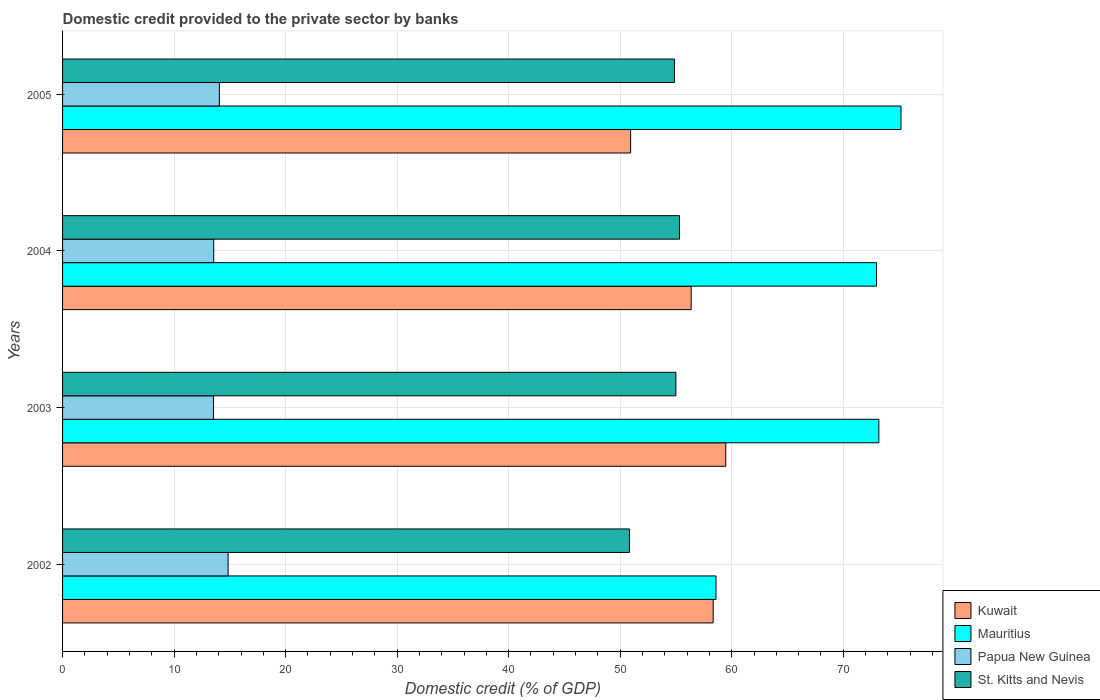How many different coloured bars are there?
Your answer should be compact. 4. How many groups of bars are there?
Offer a terse response. 4. Are the number of bars per tick equal to the number of legend labels?
Give a very brief answer. Yes. How many bars are there on the 4th tick from the top?
Ensure brevity in your answer.  4. What is the label of the 2nd group of bars from the top?
Offer a terse response. 2004. What is the domestic credit provided to the private sector by banks in St. Kitts and Nevis in 2004?
Provide a succinct answer. 55.32. Across all years, what is the maximum domestic credit provided to the private sector by banks in Mauritius?
Provide a succinct answer. 75.18. Across all years, what is the minimum domestic credit provided to the private sector by banks in Papua New Guinea?
Offer a very short reply. 13.53. In which year was the domestic credit provided to the private sector by banks in St. Kitts and Nevis minimum?
Give a very brief answer. 2002. What is the total domestic credit provided to the private sector by banks in St. Kitts and Nevis in the graph?
Ensure brevity in your answer.  216.01. What is the difference between the domestic credit provided to the private sector by banks in Kuwait in 2003 and that in 2005?
Your answer should be compact. 8.53. What is the difference between the domestic credit provided to the private sector by banks in Mauritius in 2004 and the domestic credit provided to the private sector by banks in Kuwait in 2003?
Keep it short and to the point. 13.52. What is the average domestic credit provided to the private sector by banks in St. Kitts and Nevis per year?
Give a very brief answer. 54. In the year 2003, what is the difference between the domestic credit provided to the private sector by banks in St. Kitts and Nevis and domestic credit provided to the private sector by banks in Kuwait?
Your answer should be compact. -4.47. What is the ratio of the domestic credit provided to the private sector by banks in St. Kitts and Nevis in 2002 to that in 2004?
Keep it short and to the point. 0.92. Is the domestic credit provided to the private sector by banks in Papua New Guinea in 2004 less than that in 2005?
Your response must be concise. Yes. What is the difference between the highest and the second highest domestic credit provided to the private sector by banks in St. Kitts and Nevis?
Provide a short and direct response. 0.33. What is the difference between the highest and the lowest domestic credit provided to the private sector by banks in Papua New Guinea?
Offer a very short reply. 1.31. In how many years, is the domestic credit provided to the private sector by banks in Mauritius greater than the average domestic credit provided to the private sector by banks in Mauritius taken over all years?
Make the answer very short. 3. Is the sum of the domestic credit provided to the private sector by banks in Mauritius in 2002 and 2005 greater than the maximum domestic credit provided to the private sector by banks in Kuwait across all years?
Provide a succinct answer. Yes. What does the 4th bar from the top in 2005 represents?
Provide a succinct answer. Kuwait. What does the 1st bar from the bottom in 2005 represents?
Give a very brief answer. Kuwait. How many bars are there?
Give a very brief answer. 16. How many years are there in the graph?
Ensure brevity in your answer.  4. Are the values on the major ticks of X-axis written in scientific E-notation?
Your answer should be compact. No. Does the graph contain grids?
Offer a very short reply. Yes. How are the legend labels stacked?
Offer a very short reply. Vertical. What is the title of the graph?
Your answer should be very brief. Domestic credit provided to the private sector by banks. What is the label or title of the X-axis?
Provide a short and direct response. Domestic credit (% of GDP). What is the Domestic credit (% of GDP) in Kuwait in 2002?
Offer a very short reply. 58.34. What is the Domestic credit (% of GDP) in Mauritius in 2002?
Ensure brevity in your answer.  58.59. What is the Domestic credit (% of GDP) of Papua New Guinea in 2002?
Your response must be concise. 14.84. What is the Domestic credit (% of GDP) in St. Kitts and Nevis in 2002?
Your answer should be very brief. 50.83. What is the Domestic credit (% of GDP) in Kuwait in 2003?
Your answer should be very brief. 59.47. What is the Domestic credit (% of GDP) of Mauritius in 2003?
Your answer should be compact. 73.19. What is the Domestic credit (% of GDP) of Papua New Guinea in 2003?
Your response must be concise. 13.53. What is the Domestic credit (% of GDP) of St. Kitts and Nevis in 2003?
Give a very brief answer. 54.99. What is the Domestic credit (% of GDP) of Kuwait in 2004?
Your answer should be compact. 56.36. What is the Domestic credit (% of GDP) in Mauritius in 2004?
Offer a very short reply. 72.99. What is the Domestic credit (% of GDP) of Papua New Guinea in 2004?
Your answer should be very brief. 13.56. What is the Domestic credit (% of GDP) in St. Kitts and Nevis in 2004?
Your answer should be compact. 55.32. What is the Domestic credit (% of GDP) of Kuwait in 2005?
Make the answer very short. 50.93. What is the Domestic credit (% of GDP) in Mauritius in 2005?
Give a very brief answer. 75.18. What is the Domestic credit (% of GDP) in Papua New Guinea in 2005?
Make the answer very short. 14.06. What is the Domestic credit (% of GDP) of St. Kitts and Nevis in 2005?
Your answer should be compact. 54.86. Across all years, what is the maximum Domestic credit (% of GDP) of Kuwait?
Offer a very short reply. 59.47. Across all years, what is the maximum Domestic credit (% of GDP) of Mauritius?
Offer a terse response. 75.18. Across all years, what is the maximum Domestic credit (% of GDP) of Papua New Guinea?
Give a very brief answer. 14.84. Across all years, what is the maximum Domestic credit (% of GDP) in St. Kitts and Nevis?
Provide a short and direct response. 55.32. Across all years, what is the minimum Domestic credit (% of GDP) of Kuwait?
Your answer should be compact. 50.93. Across all years, what is the minimum Domestic credit (% of GDP) in Mauritius?
Keep it short and to the point. 58.59. Across all years, what is the minimum Domestic credit (% of GDP) in Papua New Guinea?
Make the answer very short. 13.53. Across all years, what is the minimum Domestic credit (% of GDP) of St. Kitts and Nevis?
Give a very brief answer. 50.83. What is the total Domestic credit (% of GDP) in Kuwait in the graph?
Keep it short and to the point. 225.1. What is the total Domestic credit (% of GDP) in Mauritius in the graph?
Ensure brevity in your answer.  279.95. What is the total Domestic credit (% of GDP) in Papua New Guinea in the graph?
Your answer should be compact. 55.99. What is the total Domestic credit (% of GDP) of St. Kitts and Nevis in the graph?
Offer a terse response. 216.01. What is the difference between the Domestic credit (% of GDP) in Kuwait in 2002 and that in 2003?
Offer a terse response. -1.13. What is the difference between the Domestic credit (% of GDP) of Mauritius in 2002 and that in 2003?
Make the answer very short. -14.6. What is the difference between the Domestic credit (% of GDP) in Papua New Guinea in 2002 and that in 2003?
Give a very brief answer. 1.31. What is the difference between the Domestic credit (% of GDP) in St. Kitts and Nevis in 2002 and that in 2003?
Give a very brief answer. -4.16. What is the difference between the Domestic credit (% of GDP) of Kuwait in 2002 and that in 2004?
Give a very brief answer. 1.97. What is the difference between the Domestic credit (% of GDP) in Mauritius in 2002 and that in 2004?
Ensure brevity in your answer.  -14.4. What is the difference between the Domestic credit (% of GDP) in Papua New Guinea in 2002 and that in 2004?
Keep it short and to the point. 1.29. What is the difference between the Domestic credit (% of GDP) of St. Kitts and Nevis in 2002 and that in 2004?
Give a very brief answer. -4.49. What is the difference between the Domestic credit (% of GDP) of Kuwait in 2002 and that in 2005?
Ensure brevity in your answer.  7.4. What is the difference between the Domestic credit (% of GDP) in Mauritius in 2002 and that in 2005?
Your answer should be very brief. -16.59. What is the difference between the Domestic credit (% of GDP) of Papua New Guinea in 2002 and that in 2005?
Give a very brief answer. 0.78. What is the difference between the Domestic credit (% of GDP) of St. Kitts and Nevis in 2002 and that in 2005?
Your answer should be very brief. -4.03. What is the difference between the Domestic credit (% of GDP) of Kuwait in 2003 and that in 2004?
Provide a succinct answer. 3.1. What is the difference between the Domestic credit (% of GDP) of Mauritius in 2003 and that in 2004?
Offer a very short reply. 0.21. What is the difference between the Domestic credit (% of GDP) in Papua New Guinea in 2003 and that in 2004?
Provide a short and direct response. -0.03. What is the difference between the Domestic credit (% of GDP) in St. Kitts and Nevis in 2003 and that in 2004?
Your answer should be very brief. -0.33. What is the difference between the Domestic credit (% of GDP) in Kuwait in 2003 and that in 2005?
Ensure brevity in your answer.  8.53. What is the difference between the Domestic credit (% of GDP) of Mauritius in 2003 and that in 2005?
Your response must be concise. -1.98. What is the difference between the Domestic credit (% of GDP) of Papua New Guinea in 2003 and that in 2005?
Your answer should be very brief. -0.53. What is the difference between the Domestic credit (% of GDP) of St. Kitts and Nevis in 2003 and that in 2005?
Offer a terse response. 0.13. What is the difference between the Domestic credit (% of GDP) in Kuwait in 2004 and that in 2005?
Make the answer very short. 5.43. What is the difference between the Domestic credit (% of GDP) in Mauritius in 2004 and that in 2005?
Offer a very short reply. -2.19. What is the difference between the Domestic credit (% of GDP) of Papua New Guinea in 2004 and that in 2005?
Your answer should be very brief. -0.5. What is the difference between the Domestic credit (% of GDP) of St. Kitts and Nevis in 2004 and that in 2005?
Offer a terse response. 0.45. What is the difference between the Domestic credit (% of GDP) in Kuwait in 2002 and the Domestic credit (% of GDP) in Mauritius in 2003?
Provide a succinct answer. -14.86. What is the difference between the Domestic credit (% of GDP) in Kuwait in 2002 and the Domestic credit (% of GDP) in Papua New Guinea in 2003?
Your answer should be compact. 44.81. What is the difference between the Domestic credit (% of GDP) of Kuwait in 2002 and the Domestic credit (% of GDP) of St. Kitts and Nevis in 2003?
Offer a terse response. 3.34. What is the difference between the Domestic credit (% of GDP) of Mauritius in 2002 and the Domestic credit (% of GDP) of Papua New Guinea in 2003?
Your answer should be compact. 45.06. What is the difference between the Domestic credit (% of GDP) in Mauritius in 2002 and the Domestic credit (% of GDP) in St. Kitts and Nevis in 2003?
Offer a terse response. 3.6. What is the difference between the Domestic credit (% of GDP) of Papua New Guinea in 2002 and the Domestic credit (% of GDP) of St. Kitts and Nevis in 2003?
Ensure brevity in your answer.  -40.15. What is the difference between the Domestic credit (% of GDP) of Kuwait in 2002 and the Domestic credit (% of GDP) of Mauritius in 2004?
Ensure brevity in your answer.  -14.65. What is the difference between the Domestic credit (% of GDP) in Kuwait in 2002 and the Domestic credit (% of GDP) in Papua New Guinea in 2004?
Offer a very short reply. 44.78. What is the difference between the Domestic credit (% of GDP) in Kuwait in 2002 and the Domestic credit (% of GDP) in St. Kitts and Nevis in 2004?
Offer a very short reply. 3.02. What is the difference between the Domestic credit (% of GDP) in Mauritius in 2002 and the Domestic credit (% of GDP) in Papua New Guinea in 2004?
Make the answer very short. 45.04. What is the difference between the Domestic credit (% of GDP) in Mauritius in 2002 and the Domestic credit (% of GDP) in St. Kitts and Nevis in 2004?
Your answer should be very brief. 3.27. What is the difference between the Domestic credit (% of GDP) in Papua New Guinea in 2002 and the Domestic credit (% of GDP) in St. Kitts and Nevis in 2004?
Offer a terse response. -40.47. What is the difference between the Domestic credit (% of GDP) in Kuwait in 2002 and the Domestic credit (% of GDP) in Mauritius in 2005?
Offer a very short reply. -16.84. What is the difference between the Domestic credit (% of GDP) of Kuwait in 2002 and the Domestic credit (% of GDP) of Papua New Guinea in 2005?
Your answer should be very brief. 44.28. What is the difference between the Domestic credit (% of GDP) of Kuwait in 2002 and the Domestic credit (% of GDP) of St. Kitts and Nevis in 2005?
Give a very brief answer. 3.47. What is the difference between the Domestic credit (% of GDP) in Mauritius in 2002 and the Domestic credit (% of GDP) in Papua New Guinea in 2005?
Keep it short and to the point. 44.53. What is the difference between the Domestic credit (% of GDP) of Mauritius in 2002 and the Domestic credit (% of GDP) of St. Kitts and Nevis in 2005?
Your answer should be very brief. 3.73. What is the difference between the Domestic credit (% of GDP) in Papua New Guinea in 2002 and the Domestic credit (% of GDP) in St. Kitts and Nevis in 2005?
Offer a terse response. -40.02. What is the difference between the Domestic credit (% of GDP) in Kuwait in 2003 and the Domestic credit (% of GDP) in Mauritius in 2004?
Keep it short and to the point. -13.52. What is the difference between the Domestic credit (% of GDP) of Kuwait in 2003 and the Domestic credit (% of GDP) of Papua New Guinea in 2004?
Give a very brief answer. 45.91. What is the difference between the Domestic credit (% of GDP) of Kuwait in 2003 and the Domestic credit (% of GDP) of St. Kitts and Nevis in 2004?
Provide a short and direct response. 4.15. What is the difference between the Domestic credit (% of GDP) of Mauritius in 2003 and the Domestic credit (% of GDP) of Papua New Guinea in 2004?
Make the answer very short. 59.64. What is the difference between the Domestic credit (% of GDP) of Mauritius in 2003 and the Domestic credit (% of GDP) of St. Kitts and Nevis in 2004?
Offer a very short reply. 17.88. What is the difference between the Domestic credit (% of GDP) of Papua New Guinea in 2003 and the Domestic credit (% of GDP) of St. Kitts and Nevis in 2004?
Your answer should be very brief. -41.79. What is the difference between the Domestic credit (% of GDP) of Kuwait in 2003 and the Domestic credit (% of GDP) of Mauritius in 2005?
Your response must be concise. -15.71. What is the difference between the Domestic credit (% of GDP) of Kuwait in 2003 and the Domestic credit (% of GDP) of Papua New Guinea in 2005?
Your answer should be very brief. 45.41. What is the difference between the Domestic credit (% of GDP) in Kuwait in 2003 and the Domestic credit (% of GDP) in St. Kitts and Nevis in 2005?
Make the answer very short. 4.6. What is the difference between the Domestic credit (% of GDP) in Mauritius in 2003 and the Domestic credit (% of GDP) in Papua New Guinea in 2005?
Keep it short and to the point. 59.13. What is the difference between the Domestic credit (% of GDP) of Mauritius in 2003 and the Domestic credit (% of GDP) of St. Kitts and Nevis in 2005?
Offer a very short reply. 18.33. What is the difference between the Domestic credit (% of GDP) of Papua New Guinea in 2003 and the Domestic credit (% of GDP) of St. Kitts and Nevis in 2005?
Offer a terse response. -41.33. What is the difference between the Domestic credit (% of GDP) of Kuwait in 2004 and the Domestic credit (% of GDP) of Mauritius in 2005?
Provide a succinct answer. -18.81. What is the difference between the Domestic credit (% of GDP) in Kuwait in 2004 and the Domestic credit (% of GDP) in Papua New Guinea in 2005?
Keep it short and to the point. 42.3. What is the difference between the Domestic credit (% of GDP) in Kuwait in 2004 and the Domestic credit (% of GDP) in St. Kitts and Nevis in 2005?
Your answer should be compact. 1.5. What is the difference between the Domestic credit (% of GDP) in Mauritius in 2004 and the Domestic credit (% of GDP) in Papua New Guinea in 2005?
Offer a very short reply. 58.93. What is the difference between the Domestic credit (% of GDP) in Mauritius in 2004 and the Domestic credit (% of GDP) in St. Kitts and Nevis in 2005?
Provide a short and direct response. 18.12. What is the difference between the Domestic credit (% of GDP) of Papua New Guinea in 2004 and the Domestic credit (% of GDP) of St. Kitts and Nevis in 2005?
Offer a terse response. -41.31. What is the average Domestic credit (% of GDP) in Kuwait per year?
Keep it short and to the point. 56.27. What is the average Domestic credit (% of GDP) in Mauritius per year?
Offer a very short reply. 69.99. What is the average Domestic credit (% of GDP) of Papua New Guinea per year?
Your answer should be very brief. 14. What is the average Domestic credit (% of GDP) of St. Kitts and Nevis per year?
Ensure brevity in your answer.  54. In the year 2002, what is the difference between the Domestic credit (% of GDP) of Kuwait and Domestic credit (% of GDP) of Mauritius?
Offer a terse response. -0.25. In the year 2002, what is the difference between the Domestic credit (% of GDP) in Kuwait and Domestic credit (% of GDP) in Papua New Guinea?
Make the answer very short. 43.49. In the year 2002, what is the difference between the Domestic credit (% of GDP) of Kuwait and Domestic credit (% of GDP) of St. Kitts and Nevis?
Offer a very short reply. 7.51. In the year 2002, what is the difference between the Domestic credit (% of GDP) of Mauritius and Domestic credit (% of GDP) of Papua New Guinea?
Provide a short and direct response. 43.75. In the year 2002, what is the difference between the Domestic credit (% of GDP) of Mauritius and Domestic credit (% of GDP) of St. Kitts and Nevis?
Offer a very short reply. 7.76. In the year 2002, what is the difference between the Domestic credit (% of GDP) in Papua New Guinea and Domestic credit (% of GDP) in St. Kitts and Nevis?
Your answer should be very brief. -35.99. In the year 2003, what is the difference between the Domestic credit (% of GDP) of Kuwait and Domestic credit (% of GDP) of Mauritius?
Your answer should be compact. -13.73. In the year 2003, what is the difference between the Domestic credit (% of GDP) of Kuwait and Domestic credit (% of GDP) of Papua New Guinea?
Ensure brevity in your answer.  45.94. In the year 2003, what is the difference between the Domestic credit (% of GDP) in Kuwait and Domestic credit (% of GDP) in St. Kitts and Nevis?
Provide a succinct answer. 4.47. In the year 2003, what is the difference between the Domestic credit (% of GDP) of Mauritius and Domestic credit (% of GDP) of Papua New Guinea?
Provide a succinct answer. 59.66. In the year 2003, what is the difference between the Domestic credit (% of GDP) in Mauritius and Domestic credit (% of GDP) in St. Kitts and Nevis?
Give a very brief answer. 18.2. In the year 2003, what is the difference between the Domestic credit (% of GDP) in Papua New Guinea and Domestic credit (% of GDP) in St. Kitts and Nevis?
Offer a very short reply. -41.46. In the year 2004, what is the difference between the Domestic credit (% of GDP) in Kuwait and Domestic credit (% of GDP) in Mauritius?
Your answer should be very brief. -16.62. In the year 2004, what is the difference between the Domestic credit (% of GDP) in Kuwait and Domestic credit (% of GDP) in Papua New Guinea?
Make the answer very short. 42.81. In the year 2004, what is the difference between the Domestic credit (% of GDP) of Kuwait and Domestic credit (% of GDP) of St. Kitts and Nevis?
Your response must be concise. 1.05. In the year 2004, what is the difference between the Domestic credit (% of GDP) of Mauritius and Domestic credit (% of GDP) of Papua New Guinea?
Make the answer very short. 59.43. In the year 2004, what is the difference between the Domestic credit (% of GDP) in Mauritius and Domestic credit (% of GDP) in St. Kitts and Nevis?
Provide a short and direct response. 17.67. In the year 2004, what is the difference between the Domestic credit (% of GDP) of Papua New Guinea and Domestic credit (% of GDP) of St. Kitts and Nevis?
Offer a terse response. -41.76. In the year 2005, what is the difference between the Domestic credit (% of GDP) in Kuwait and Domestic credit (% of GDP) in Mauritius?
Your response must be concise. -24.24. In the year 2005, what is the difference between the Domestic credit (% of GDP) of Kuwait and Domestic credit (% of GDP) of Papua New Guinea?
Provide a short and direct response. 36.87. In the year 2005, what is the difference between the Domestic credit (% of GDP) in Kuwait and Domestic credit (% of GDP) in St. Kitts and Nevis?
Ensure brevity in your answer.  -3.93. In the year 2005, what is the difference between the Domestic credit (% of GDP) of Mauritius and Domestic credit (% of GDP) of Papua New Guinea?
Keep it short and to the point. 61.12. In the year 2005, what is the difference between the Domestic credit (% of GDP) in Mauritius and Domestic credit (% of GDP) in St. Kitts and Nevis?
Give a very brief answer. 20.31. In the year 2005, what is the difference between the Domestic credit (% of GDP) in Papua New Guinea and Domestic credit (% of GDP) in St. Kitts and Nevis?
Your response must be concise. -40.8. What is the ratio of the Domestic credit (% of GDP) in Mauritius in 2002 to that in 2003?
Your answer should be very brief. 0.8. What is the ratio of the Domestic credit (% of GDP) in Papua New Guinea in 2002 to that in 2003?
Ensure brevity in your answer.  1.1. What is the ratio of the Domestic credit (% of GDP) in St. Kitts and Nevis in 2002 to that in 2003?
Your response must be concise. 0.92. What is the ratio of the Domestic credit (% of GDP) of Kuwait in 2002 to that in 2004?
Give a very brief answer. 1.03. What is the ratio of the Domestic credit (% of GDP) of Mauritius in 2002 to that in 2004?
Make the answer very short. 0.8. What is the ratio of the Domestic credit (% of GDP) of Papua New Guinea in 2002 to that in 2004?
Your response must be concise. 1.1. What is the ratio of the Domestic credit (% of GDP) in St. Kitts and Nevis in 2002 to that in 2004?
Your answer should be very brief. 0.92. What is the ratio of the Domestic credit (% of GDP) in Kuwait in 2002 to that in 2005?
Ensure brevity in your answer.  1.15. What is the ratio of the Domestic credit (% of GDP) in Mauritius in 2002 to that in 2005?
Make the answer very short. 0.78. What is the ratio of the Domestic credit (% of GDP) in Papua New Guinea in 2002 to that in 2005?
Make the answer very short. 1.06. What is the ratio of the Domestic credit (% of GDP) of St. Kitts and Nevis in 2002 to that in 2005?
Your response must be concise. 0.93. What is the ratio of the Domestic credit (% of GDP) of Kuwait in 2003 to that in 2004?
Ensure brevity in your answer.  1.05. What is the ratio of the Domestic credit (% of GDP) in Kuwait in 2003 to that in 2005?
Make the answer very short. 1.17. What is the ratio of the Domestic credit (% of GDP) in Mauritius in 2003 to that in 2005?
Offer a very short reply. 0.97. What is the ratio of the Domestic credit (% of GDP) of Papua New Guinea in 2003 to that in 2005?
Your answer should be very brief. 0.96. What is the ratio of the Domestic credit (% of GDP) in St. Kitts and Nevis in 2003 to that in 2005?
Provide a succinct answer. 1. What is the ratio of the Domestic credit (% of GDP) of Kuwait in 2004 to that in 2005?
Provide a short and direct response. 1.11. What is the ratio of the Domestic credit (% of GDP) of Mauritius in 2004 to that in 2005?
Your response must be concise. 0.97. What is the ratio of the Domestic credit (% of GDP) in Papua New Guinea in 2004 to that in 2005?
Give a very brief answer. 0.96. What is the ratio of the Domestic credit (% of GDP) of St. Kitts and Nevis in 2004 to that in 2005?
Make the answer very short. 1.01. What is the difference between the highest and the second highest Domestic credit (% of GDP) of Kuwait?
Make the answer very short. 1.13. What is the difference between the highest and the second highest Domestic credit (% of GDP) in Mauritius?
Make the answer very short. 1.98. What is the difference between the highest and the second highest Domestic credit (% of GDP) of Papua New Guinea?
Offer a terse response. 0.78. What is the difference between the highest and the second highest Domestic credit (% of GDP) in St. Kitts and Nevis?
Provide a succinct answer. 0.33. What is the difference between the highest and the lowest Domestic credit (% of GDP) in Kuwait?
Make the answer very short. 8.53. What is the difference between the highest and the lowest Domestic credit (% of GDP) of Mauritius?
Make the answer very short. 16.59. What is the difference between the highest and the lowest Domestic credit (% of GDP) of Papua New Guinea?
Your answer should be compact. 1.31. What is the difference between the highest and the lowest Domestic credit (% of GDP) in St. Kitts and Nevis?
Offer a very short reply. 4.49. 